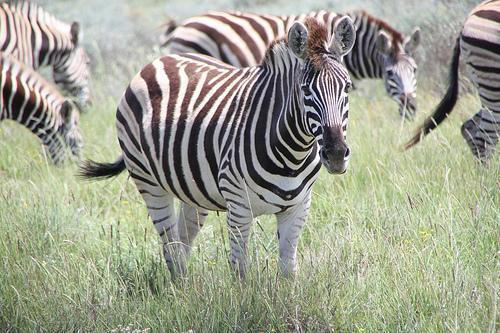How many ears does the zebra have?
Give a very brief answer. 2. How many zebra's are there?
Give a very brief answer. 5. How many zebras are there?
Give a very brief answer. 5. How many ears does a zebra have?
Give a very brief answer. 2. How many zebras look at camera?
Give a very brief answer. 2. How many legs in this box?
Give a very brief answer. 4. How many legs does the zebra have?
Give a very brief answer. 4. 